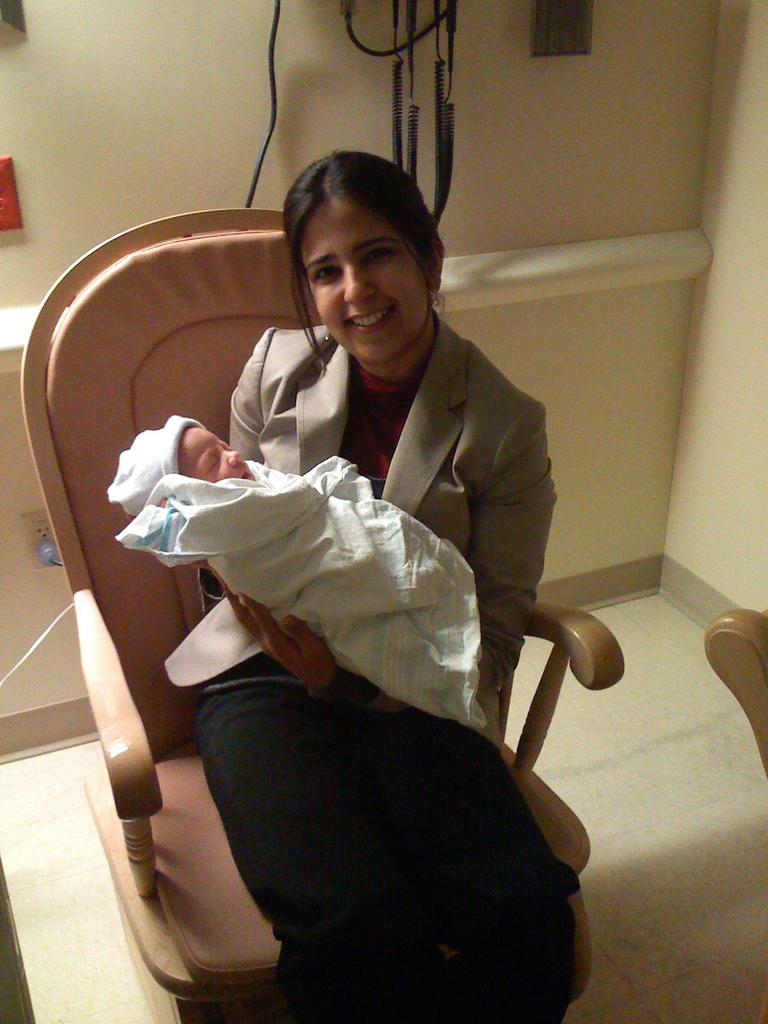Who is the main subject in the image? There is a woman in the image. What is the woman doing in the image? The woman is sitting on a chair and holding a baby. What is the woman's facial expression in the image? The woman has a smile on her face. What is the woman wearing in the image? The woman is wearing a blazer. What type of clock is the woman running in the image? There is no clock or running depicted in the image; it features a woman sitting on a chair and holding a baby. 